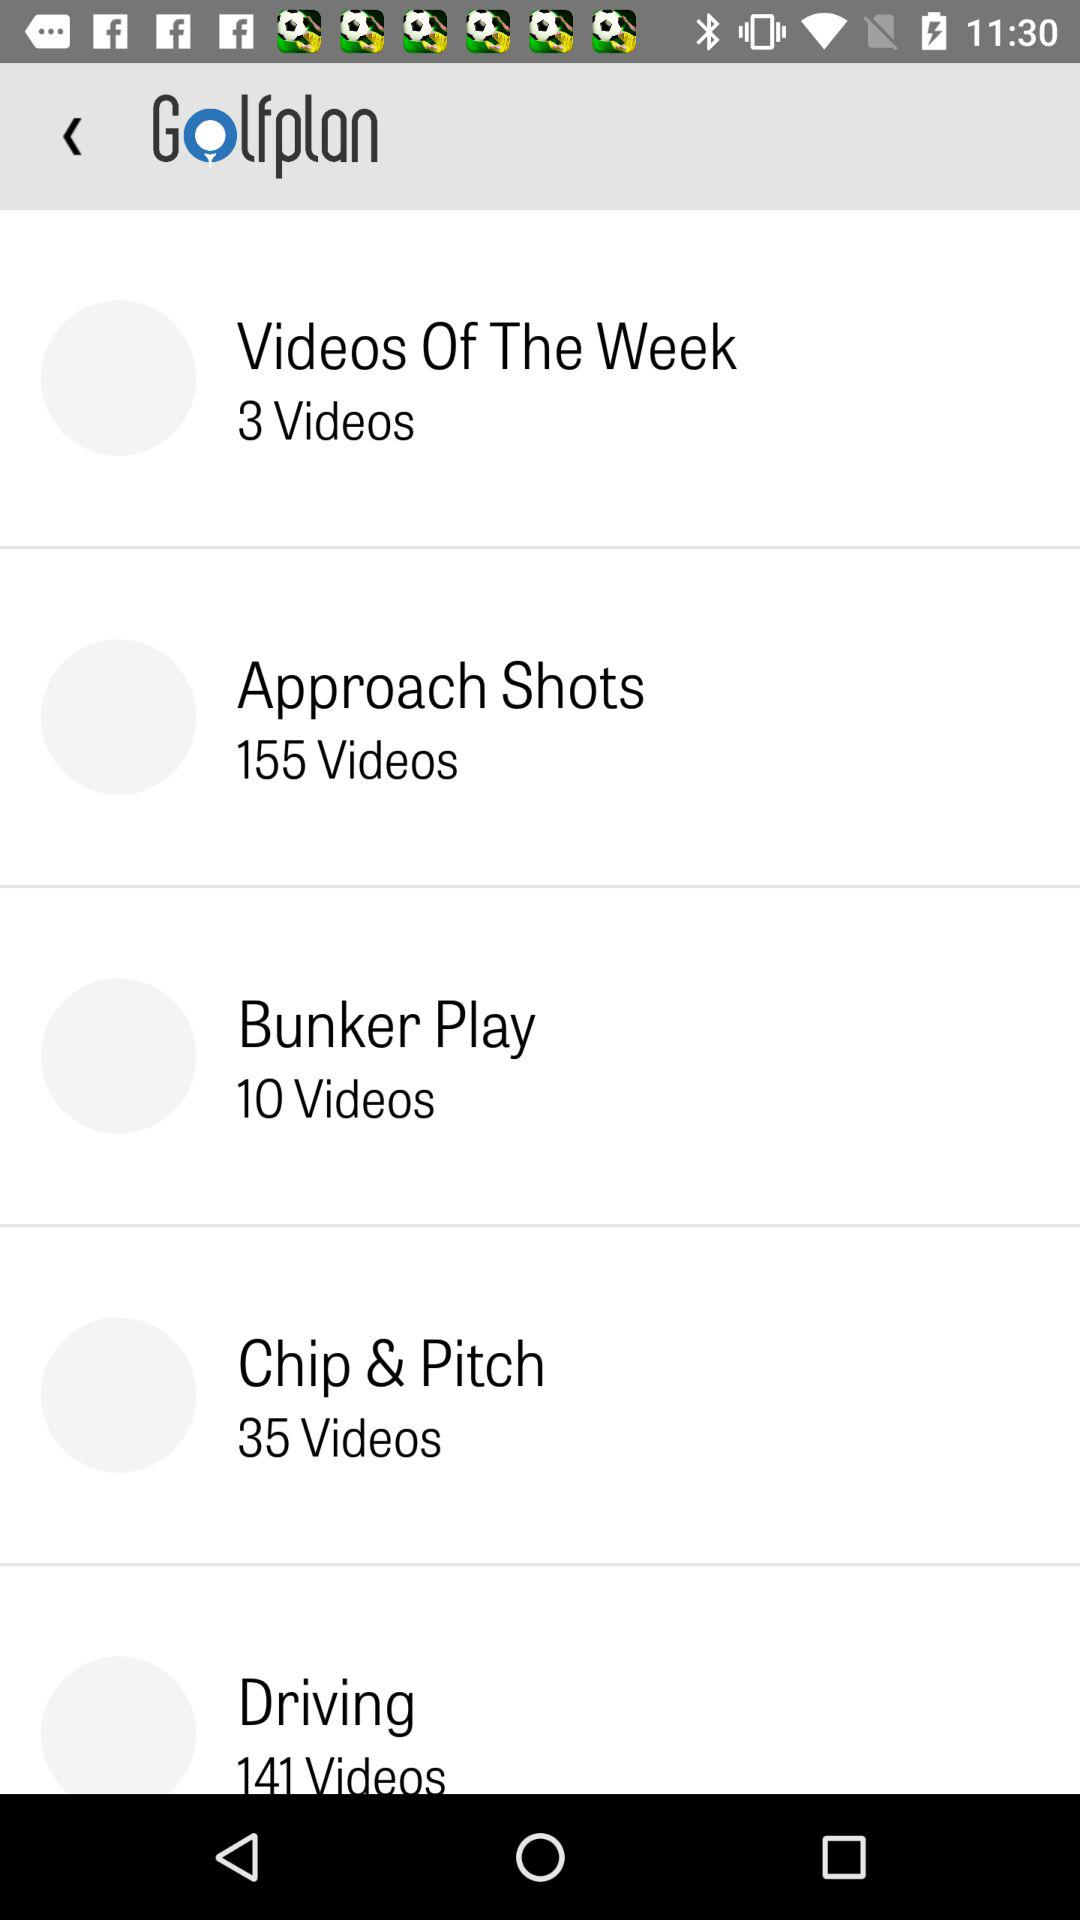How many videos does "Driving" have? There are 141 videos. 